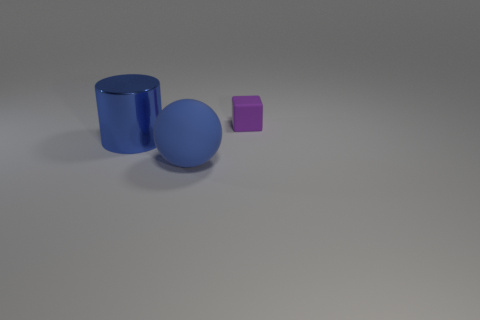Add 2 shiny objects. How many objects exist? 5 Subtract all blocks. How many objects are left? 2 Subtract 0 purple cylinders. How many objects are left? 3 Subtract all big shiny objects. Subtract all blue metallic things. How many objects are left? 1 Add 2 blue rubber spheres. How many blue rubber spheres are left? 3 Add 2 cylinders. How many cylinders exist? 3 